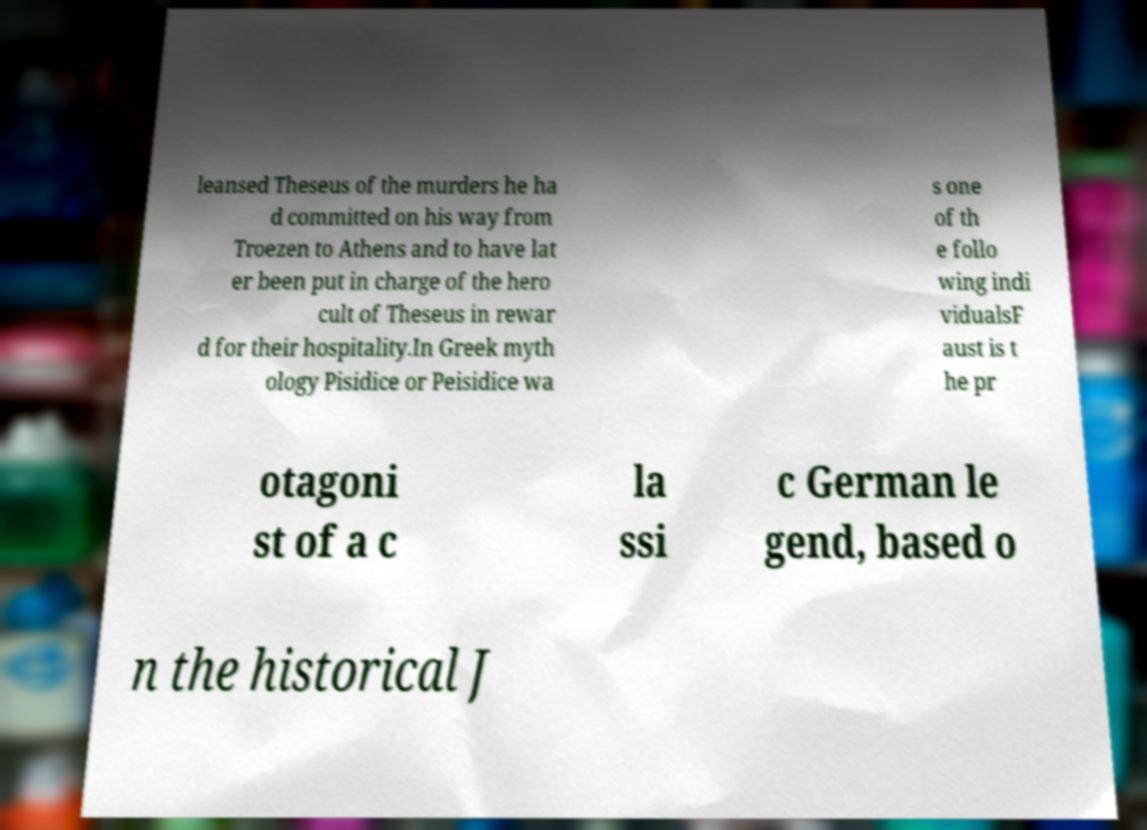Please identify and transcribe the text found in this image. leansed Theseus of the murders he ha d committed on his way from Troezen to Athens and to have lat er been put in charge of the hero cult of Theseus in rewar d for their hospitality.In Greek myth ology Pisidice or Peisidice wa s one of th e follo wing indi vidualsF aust is t he pr otagoni st of a c la ssi c German le gend, based o n the historical J 